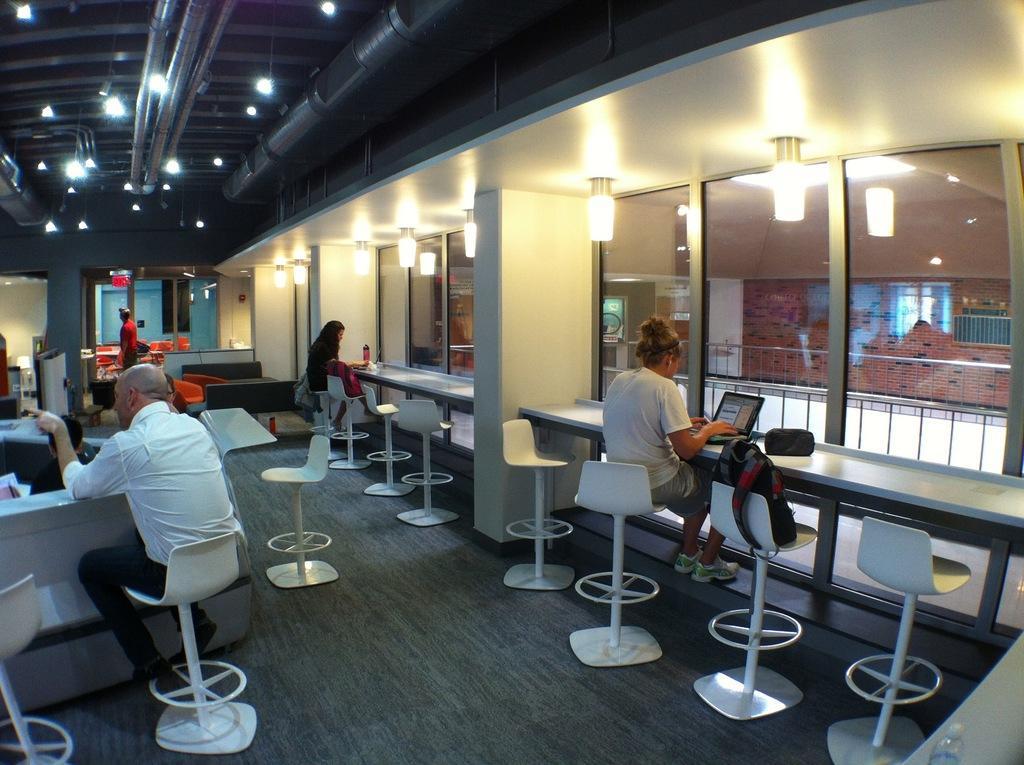Describe this image in one or two sentences. This image consists of many people. They are sitting on the chairs. At the bottom, there is a floor. The chairs are in white color. On the left, there is a table. At the top, there is a roof along with lights. On the right, there are windows. 